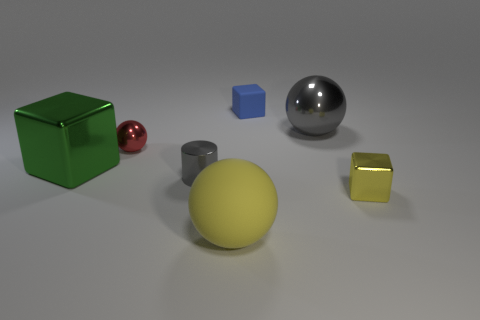What is the material of the object that is the same color as the tiny cylinder?
Make the answer very short. Metal. There is a shiny sphere to the right of the big yellow matte thing; what number of blocks are in front of it?
Offer a terse response. 2. There is a big block left of the yellow ball; does it have the same color as the tiny thing in front of the tiny shiny cylinder?
Provide a succinct answer. No. There is a gray cylinder that is the same size as the blue matte thing; what is its material?
Make the answer very short. Metal. The large object in front of the yellow object on the right side of the gray shiny object that is on the right side of the small matte block is what shape?
Your response must be concise. Sphere. There is a gray metallic thing that is the same size as the yellow matte sphere; what shape is it?
Your answer should be compact. Sphere. There is a small block behind the shiny object that is in front of the tiny gray cylinder; what number of gray shiny balls are behind it?
Offer a very short reply. 0. Is the number of tiny shiny balls that are in front of the green thing greater than the number of small blue blocks in front of the tiny yellow shiny object?
Provide a succinct answer. No. What number of other big objects are the same shape as the yellow shiny thing?
Your answer should be very brief. 1. How many things are metallic things that are to the left of the big rubber sphere or big things in front of the tiny yellow cube?
Provide a short and direct response. 4. 